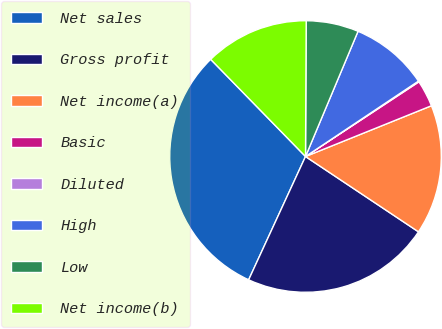Convert chart to OTSL. <chart><loc_0><loc_0><loc_500><loc_500><pie_chart><fcel>Net sales<fcel>Gross profit<fcel>Net income(a)<fcel>Basic<fcel>Diluted<fcel>High<fcel>Low<fcel>Net income(b)<nl><fcel>30.82%<fcel>22.52%<fcel>15.46%<fcel>3.17%<fcel>0.1%<fcel>9.31%<fcel>6.24%<fcel>12.39%<nl></chart> 